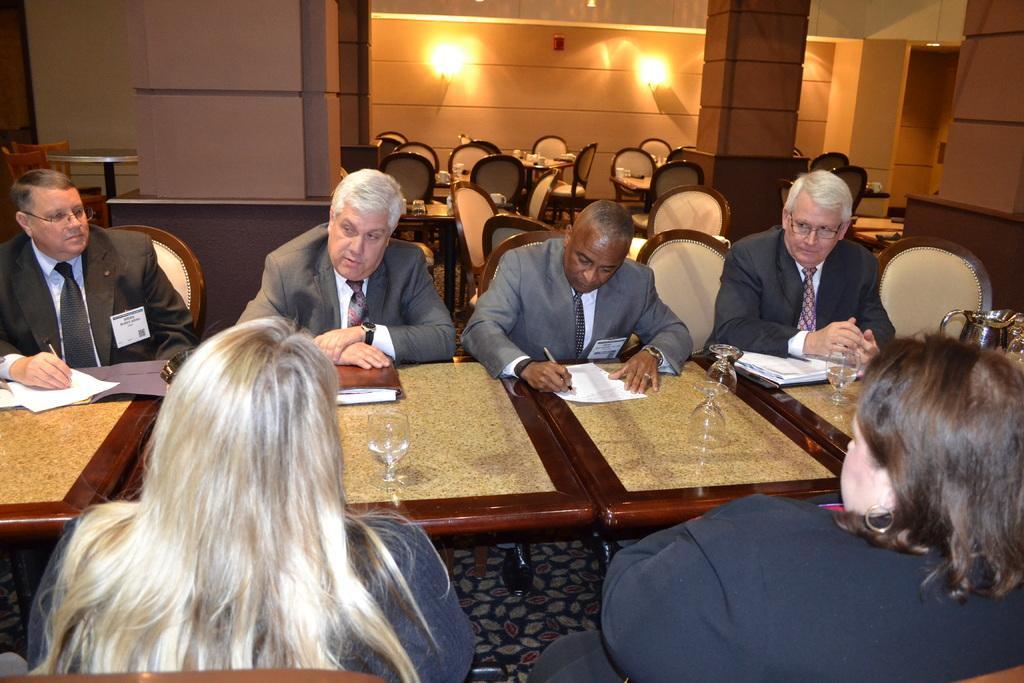Please provide a concise description of this image. In this image I can see the group of people with different color dresses. I can see these people are sitting in-front of the table. On the table I can see the papers, glasses and jug. In the background I can see many chairs and few objects on the table. I can also see the lights to the wall. 